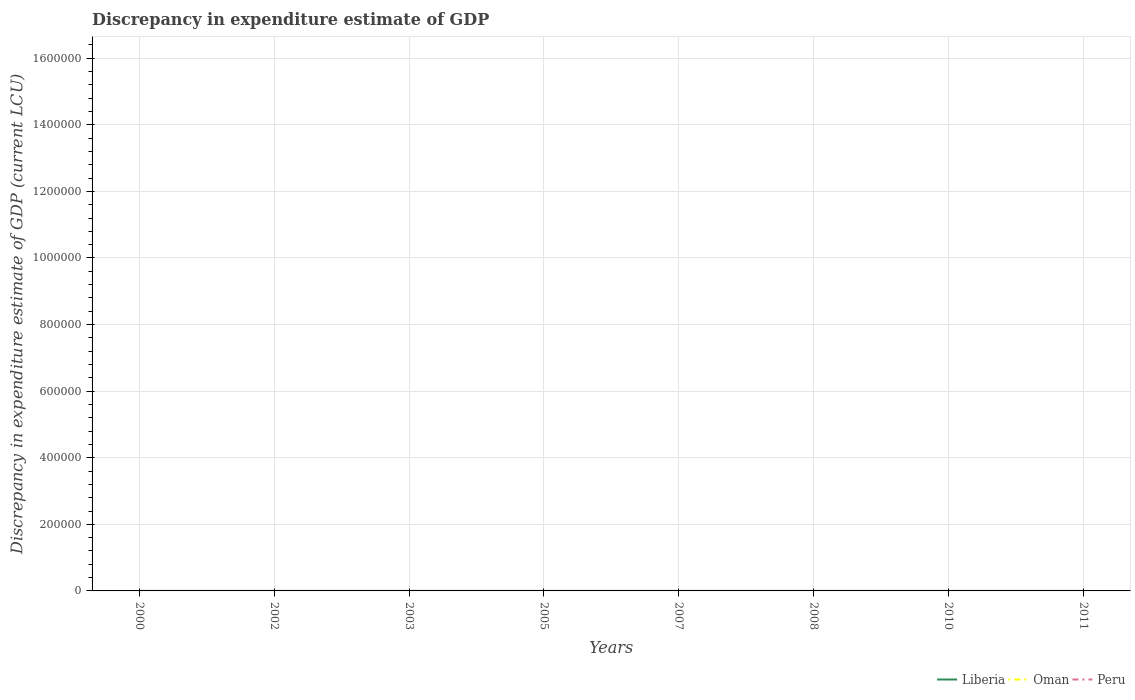How many different coloured lines are there?
Offer a terse response. 2. Is the number of lines equal to the number of legend labels?
Give a very brief answer. No. Across all years, what is the maximum discrepancy in expenditure estimate of GDP in Peru?
Ensure brevity in your answer.  0. What is the total discrepancy in expenditure estimate of GDP in Peru in the graph?
Your response must be concise. -3.8e-5. What is the difference between the highest and the second highest discrepancy in expenditure estimate of GDP in Peru?
Your response must be concise. 6e-5. Is the discrepancy in expenditure estimate of GDP in Peru strictly greater than the discrepancy in expenditure estimate of GDP in Oman over the years?
Provide a succinct answer. No. How many lines are there?
Keep it short and to the point. 2. How many years are there in the graph?
Your answer should be compact. 8. Are the values on the major ticks of Y-axis written in scientific E-notation?
Provide a short and direct response. No. Does the graph contain any zero values?
Offer a terse response. Yes. How many legend labels are there?
Make the answer very short. 3. What is the title of the graph?
Your answer should be very brief. Discrepancy in expenditure estimate of GDP. What is the label or title of the X-axis?
Your answer should be very brief. Years. What is the label or title of the Y-axis?
Provide a short and direct response. Discrepancy in expenditure estimate of GDP (current LCU). What is the Discrepancy in expenditure estimate of GDP (current LCU) in Oman in 2000?
Make the answer very short. 0. What is the Discrepancy in expenditure estimate of GDP (current LCU) of Liberia in 2002?
Ensure brevity in your answer.  0. What is the Discrepancy in expenditure estimate of GDP (current LCU) in Oman in 2002?
Your answer should be very brief. 0. What is the Discrepancy in expenditure estimate of GDP (current LCU) of Peru in 2002?
Your answer should be compact. 0. What is the Discrepancy in expenditure estimate of GDP (current LCU) in Liberia in 2003?
Give a very brief answer. 3e-8. What is the Discrepancy in expenditure estimate of GDP (current LCU) in Liberia in 2005?
Ensure brevity in your answer.  1.7e-8. What is the Discrepancy in expenditure estimate of GDP (current LCU) in Peru in 2005?
Offer a very short reply. 2.2e-5. What is the Discrepancy in expenditure estimate of GDP (current LCU) of Oman in 2007?
Offer a very short reply. 0. What is the Discrepancy in expenditure estimate of GDP (current LCU) in Peru in 2007?
Offer a very short reply. 6e-5. What is the Discrepancy in expenditure estimate of GDP (current LCU) of Liberia in 2008?
Ensure brevity in your answer.  4.86e-6. What is the Discrepancy in expenditure estimate of GDP (current LCU) in Oman in 2008?
Provide a short and direct response. 0. What is the Discrepancy in expenditure estimate of GDP (current LCU) in Peru in 2008?
Your answer should be very brief. 0. What is the Discrepancy in expenditure estimate of GDP (current LCU) of Liberia in 2010?
Ensure brevity in your answer.  0. What is the Discrepancy in expenditure estimate of GDP (current LCU) of Oman in 2010?
Make the answer very short. 0. What is the Discrepancy in expenditure estimate of GDP (current LCU) in Peru in 2010?
Offer a very short reply. 0. What is the Discrepancy in expenditure estimate of GDP (current LCU) in Liberia in 2011?
Your response must be concise. 4.83e-6. What is the Discrepancy in expenditure estimate of GDP (current LCU) in Oman in 2011?
Your answer should be very brief. 0. What is the Discrepancy in expenditure estimate of GDP (current LCU) in Peru in 2011?
Give a very brief answer. 0. Across all years, what is the maximum Discrepancy in expenditure estimate of GDP (current LCU) in Liberia?
Offer a terse response. 4.86e-6. Across all years, what is the maximum Discrepancy in expenditure estimate of GDP (current LCU) in Peru?
Your response must be concise. 6e-5. Across all years, what is the minimum Discrepancy in expenditure estimate of GDP (current LCU) in Peru?
Offer a very short reply. 0. What is the total Discrepancy in expenditure estimate of GDP (current LCU) of Liberia in the graph?
Offer a very short reply. 0. What is the total Discrepancy in expenditure estimate of GDP (current LCU) of Oman in the graph?
Give a very brief answer. 0. What is the total Discrepancy in expenditure estimate of GDP (current LCU) of Peru in the graph?
Give a very brief answer. 0. What is the difference between the Discrepancy in expenditure estimate of GDP (current LCU) of Liberia in 2003 and that in 2005?
Ensure brevity in your answer.  0. What is the difference between the Discrepancy in expenditure estimate of GDP (current LCU) of Liberia in 2003 and that in 2008?
Make the answer very short. -0. What is the difference between the Discrepancy in expenditure estimate of GDP (current LCU) of Liberia in 2003 and that in 2011?
Give a very brief answer. -0. What is the difference between the Discrepancy in expenditure estimate of GDP (current LCU) of Peru in 2005 and that in 2007?
Give a very brief answer. -0. What is the difference between the Discrepancy in expenditure estimate of GDP (current LCU) in Liberia in 2003 and the Discrepancy in expenditure estimate of GDP (current LCU) in Peru in 2005?
Offer a very short reply. -0. What is the difference between the Discrepancy in expenditure estimate of GDP (current LCU) in Liberia in 2003 and the Discrepancy in expenditure estimate of GDP (current LCU) in Peru in 2007?
Offer a terse response. -0. What is the difference between the Discrepancy in expenditure estimate of GDP (current LCU) in Liberia in 2005 and the Discrepancy in expenditure estimate of GDP (current LCU) in Peru in 2007?
Provide a succinct answer. -0. What is the average Discrepancy in expenditure estimate of GDP (current LCU) in Oman per year?
Offer a very short reply. 0. What is the average Discrepancy in expenditure estimate of GDP (current LCU) in Peru per year?
Your answer should be compact. 0. In the year 2005, what is the difference between the Discrepancy in expenditure estimate of GDP (current LCU) of Liberia and Discrepancy in expenditure estimate of GDP (current LCU) of Peru?
Keep it short and to the point. -0. What is the ratio of the Discrepancy in expenditure estimate of GDP (current LCU) of Liberia in 2003 to that in 2005?
Offer a very short reply. 1.76. What is the ratio of the Discrepancy in expenditure estimate of GDP (current LCU) in Liberia in 2003 to that in 2008?
Your answer should be very brief. 0.01. What is the ratio of the Discrepancy in expenditure estimate of GDP (current LCU) of Liberia in 2003 to that in 2011?
Offer a terse response. 0.01. What is the ratio of the Discrepancy in expenditure estimate of GDP (current LCU) in Peru in 2005 to that in 2007?
Give a very brief answer. 0.37. What is the ratio of the Discrepancy in expenditure estimate of GDP (current LCU) of Liberia in 2005 to that in 2008?
Provide a short and direct response. 0. What is the ratio of the Discrepancy in expenditure estimate of GDP (current LCU) in Liberia in 2005 to that in 2011?
Your response must be concise. 0. What is the difference between the highest and the lowest Discrepancy in expenditure estimate of GDP (current LCU) of Peru?
Give a very brief answer. 0. 